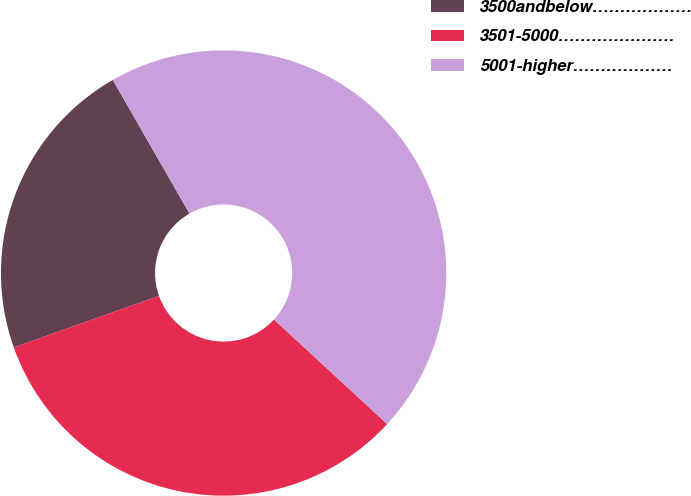<chart> <loc_0><loc_0><loc_500><loc_500><pie_chart><fcel>3500andbelow………………<fcel>3501-5000…………………<fcel>5001-higher………………<nl><fcel>22.13%<fcel>32.71%<fcel>45.16%<nl></chart> 